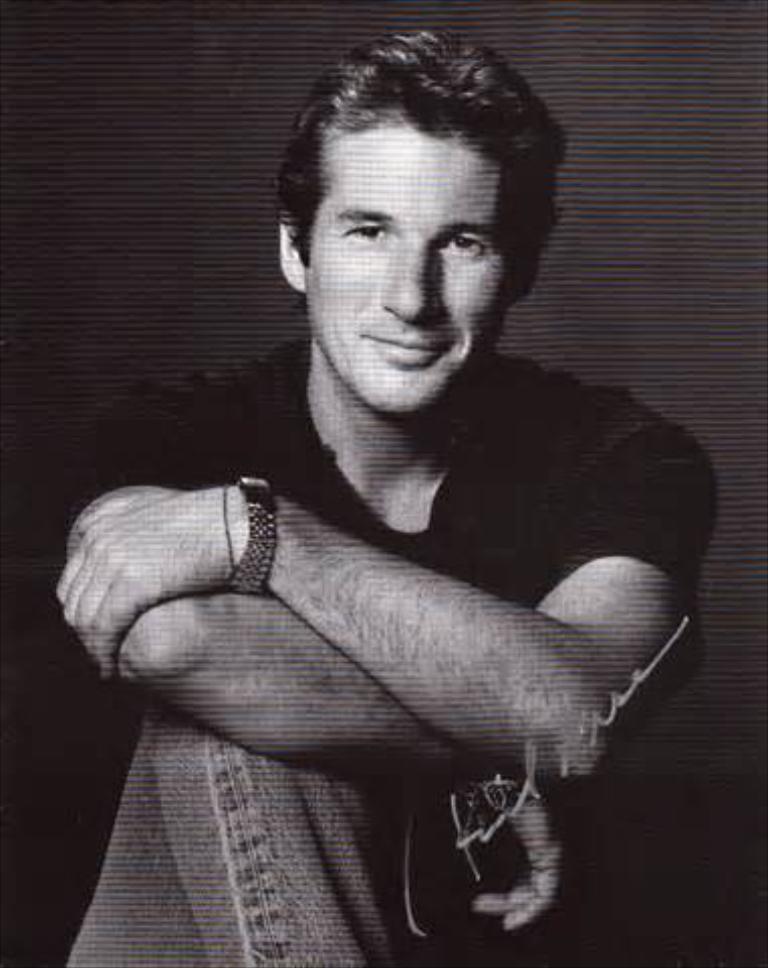Could you give a brief overview of what you see in this image? In this image we can see one man sitting, some text on the image and there is a black background. 